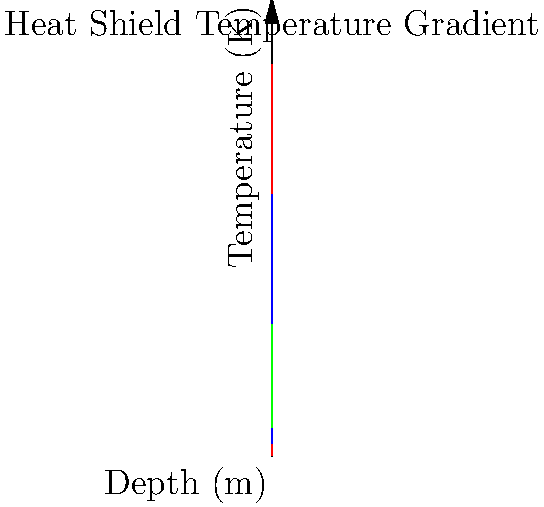Based on the temperature gradient graph for three different heat shield materials (A, B, and C), which material would be most suitable for a spacecraft re-entry heat shield if the maximum allowable temperature at a depth of 0.1 m is 1500 K? To determine the most suitable material, we need to analyze the temperature gradients for each material at a depth of 0.1 m:

1. Material A (red line):
   At x = 0.1 m, T ≈ 400 K

2. Material B (blue line):
   At x = 0.1 m, T ≈ 750 K

3. Material C (green line):
   At x = 0.1 m, T ≈ 600 K

The maximum allowable temperature at 0.1 m depth is 1500 K. All three materials have temperatures below this threshold at 0.1 m depth.

However, we need to consider the overall heat dissipation:

1. Material A has the steepest gradient, dissipating heat most rapidly but with the highest surface temperature.
2. Material C has the shallowest gradient, dissipating heat more slowly but with the lowest surface temperature.
3. Material B offers a balance between rapid heat dissipation and lower surface temperature.

Given that all materials meet the 1500 K requirement at 0.1 m depth, the best choice would be Material B. It provides:

1. Faster heat dissipation than Material C
2. Lower surface temperature than Material A
3. A good balance between heat dissipation and temperature control

This balance is crucial for protecting both the outer and inner layers of the spacecraft during re-entry.
Answer: Material B 